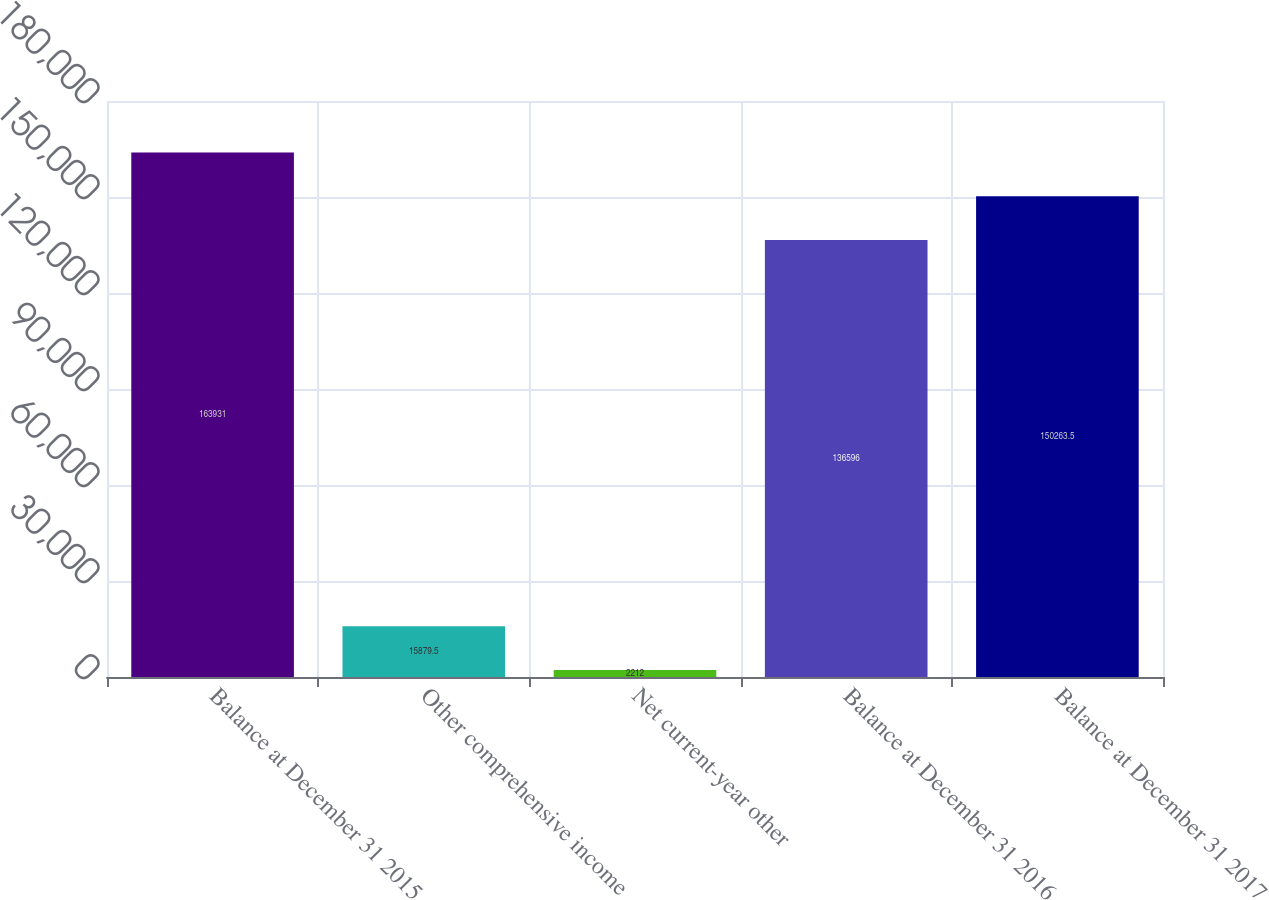<chart> <loc_0><loc_0><loc_500><loc_500><bar_chart><fcel>Balance at December 31 2015<fcel>Other comprehensive income<fcel>Net current-year other<fcel>Balance at December 31 2016<fcel>Balance at December 31 2017<nl><fcel>163931<fcel>15879.5<fcel>2212<fcel>136596<fcel>150264<nl></chart> 